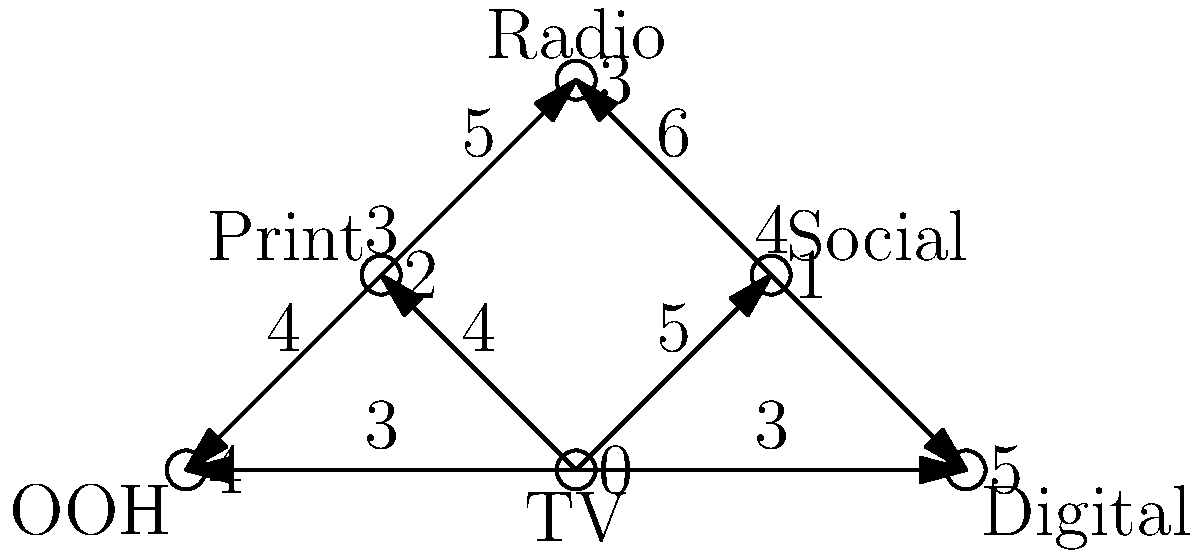Given the network graph representing different media channels and their influence on each other, what is the minimum number of channels you need to directly advertise on to indirectly reach all other channels, and which channels should you choose to maximize your reach while minimizing costs? To solve this problem, we need to find the minimum dominating set in the given graph. A dominating set is a subset of vertices such that every vertex not in the subset is adjacent to at least one vertex in the subset. The minimum dominating set is the smallest such subset.

Let's approach this step-by-step:

1. Analyze the graph:
   - We have 6 vertices (0 to 5) representing different media channels.
   - Each edge represents the influence between channels, with weights indicating the strength of influence.

2. Identify the most connected vertices:
   - Vertex 0 (TV) is connected to 4 other vertices.
   - Vertex 3 (Radio) is connected to 4 other vertices.

3. Check if selecting vertices 0 and 3 covers all other vertices:
   - Vertex 0 covers 1, 2, 4, and 5.
   - Vertex 3 covers 1, 2, 4, and 5.
   - Together, they cover all vertices.

4. Verify if we can reduce the set further:
   - Removing either 0 or 3 would leave some vertices uncovered.
   - Therefore, this is the minimum dominating set.

5. Interpret the result:
   - The minimum number of channels to directly advertise on is 2.
   - These channels are TV (vertex 0) and Radio (vertex 3).

6. Consider the weights:
   - The total weight of edges from TV and Radio to other channels is:
     TV: 5 + 4 + 3 + 3 = 15
     Radio: 6 + 5 + 3 + 4 = 18
   - This indicates that Radio has a slightly higher overall influence.

Therefore, by directly advertising on TV and Radio channels, you can indirectly reach all other channels while minimizing costs and maximizing reach.
Answer: 2 channels: TV and Radio 